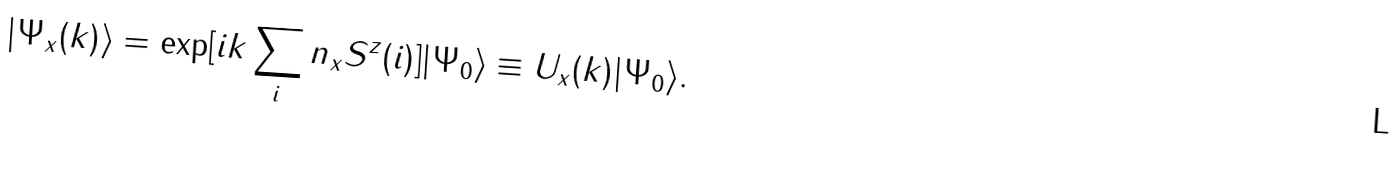Convert formula to latex. <formula><loc_0><loc_0><loc_500><loc_500>| \Psi _ { x } ( k ) \rangle = \exp [ i k \sum _ { i } n _ { x } S ^ { z } ( { i ) ] } | \Psi _ { 0 } \rangle \equiv U _ { x } ( k ) | \Psi _ { 0 } \rangle .</formula> 